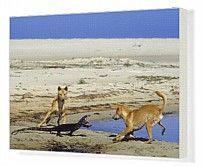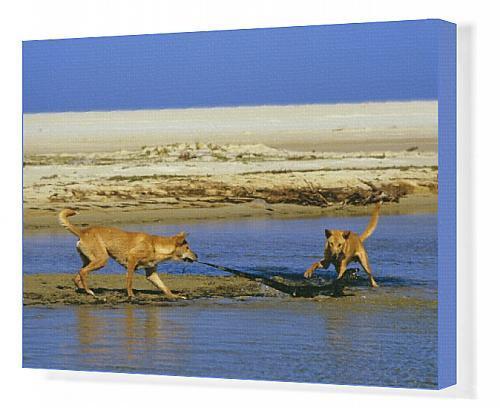The first image is the image on the left, the second image is the image on the right. For the images displayed, is the sentence "In each image there are a pair of dogs on a shore attacking a large lizard." factually correct? Answer yes or no. Yes. 